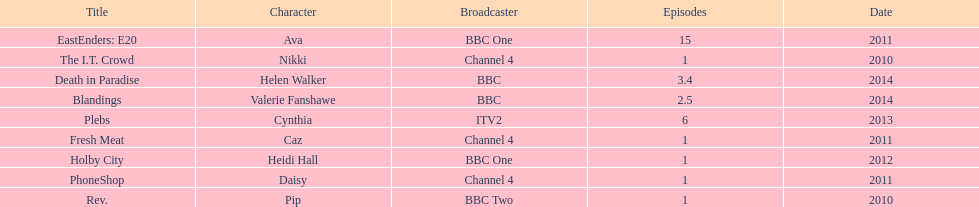How many titles have at least 5 episodes? 2. 